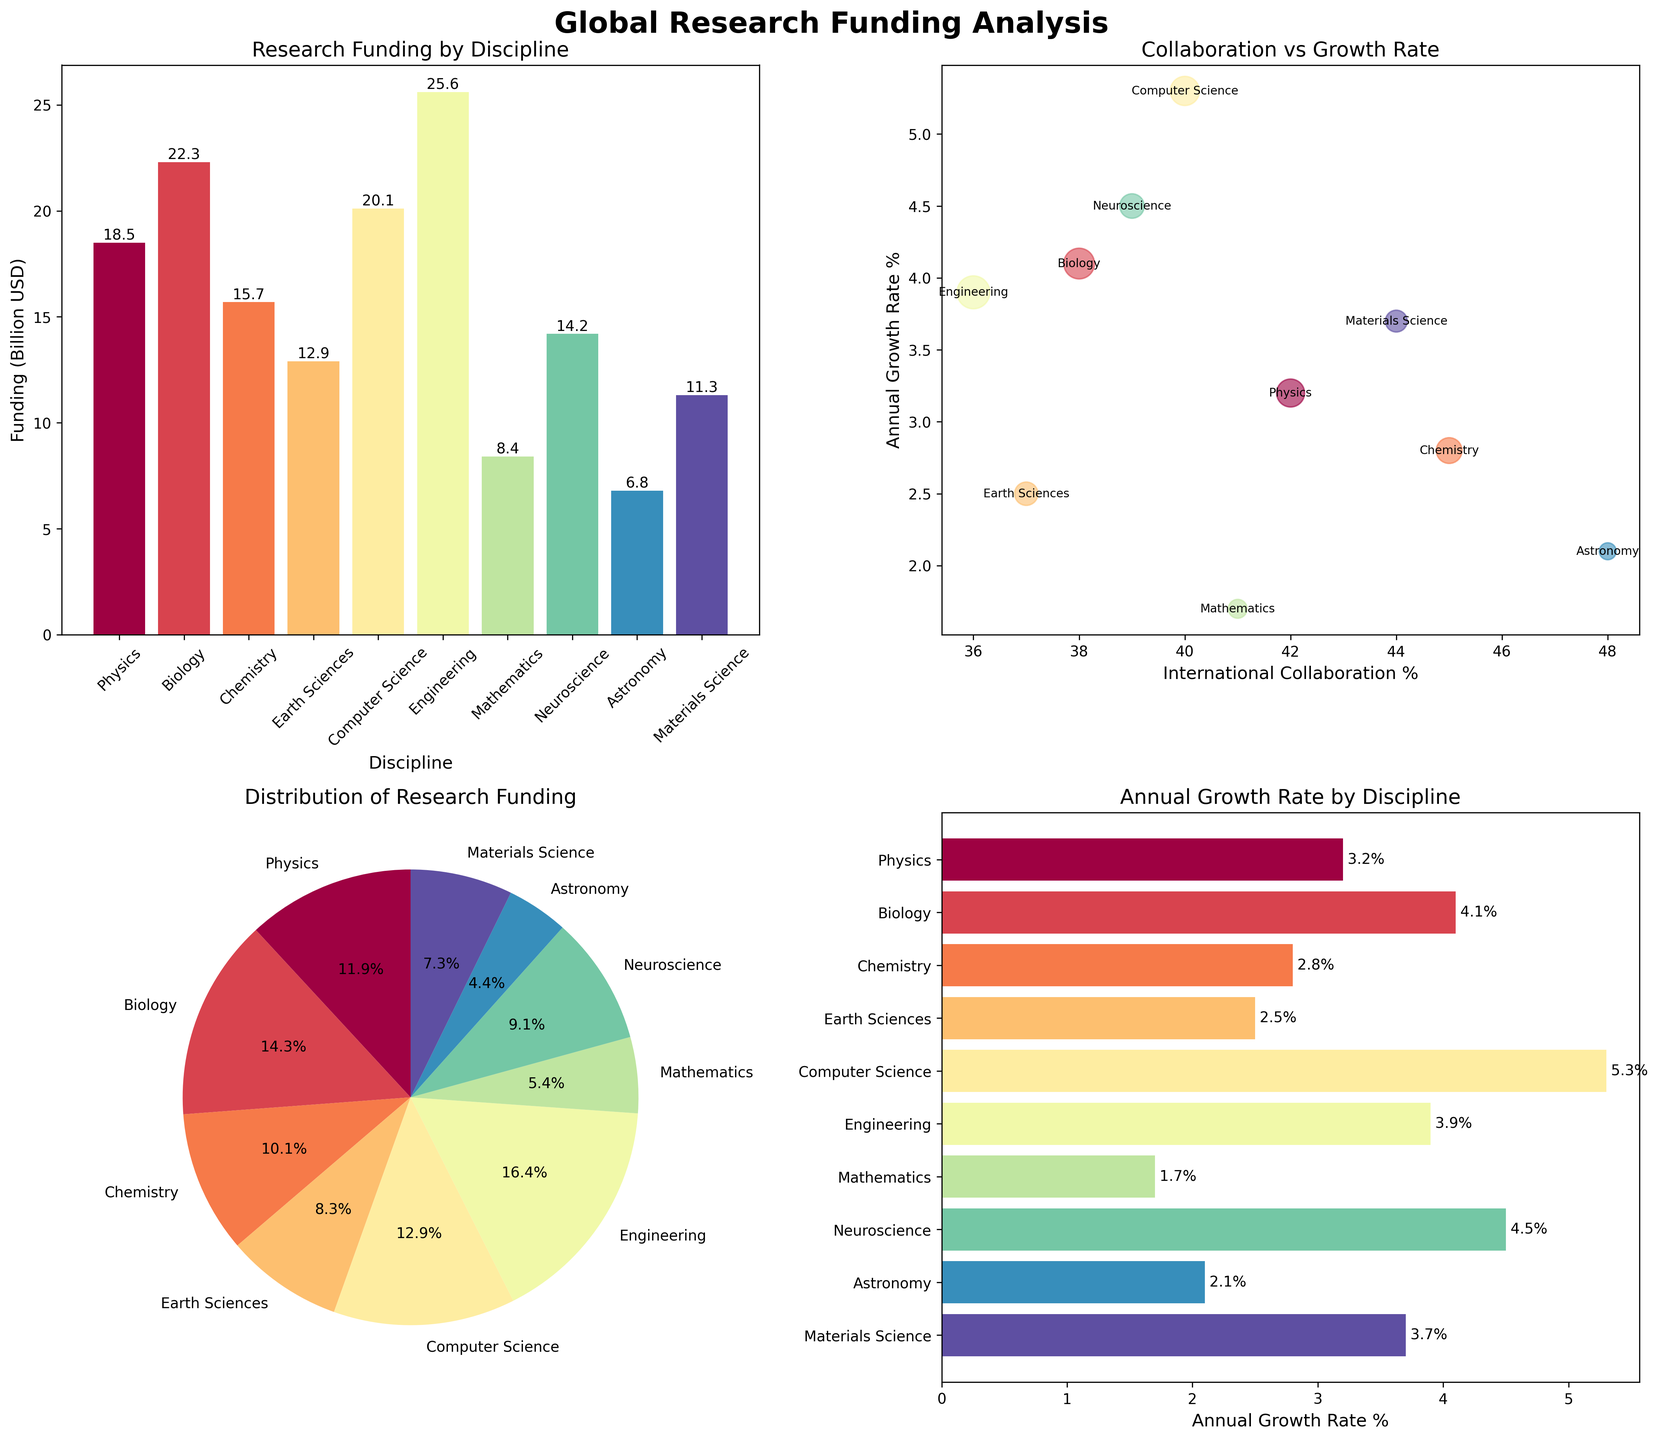What is the title of the bar plot in the figure? The bar plot is the first subplot in the figure’s top-left corner. The title is clearly written above the plot.
Answer: Research Funding by Discipline Which discipline has the highest research funding? In the bar plot, the height of each bar represents funding amounts. The tallest bar corresponds to the highest funding.
Answer: Engineering What is the total research funding across all disciplines? Add together the values of research funding for all the bars in the bar plot. The sum is 18.5 + 22.3 + 15.7 + 12.9 + 20.1 + 25.6 + 8.4 + 14.2 + 6.8 + 11.3.
Answer: 155.8 Billion USD Which discipline has the smallest annual growth rate, and what is it? In the horizontal bar chart, look for the shortest bar, which represents the smallest growth rate. The y-axis labels indicate the corresponding discipline.
Answer: Mathematics, 1.7% How much more funding does Biology receive compared to Mathematics? Compare the heights of the bars in the bar plot for Biology and Mathematics. Subtract Mathematics' funding from Biology's funding: 22.3 - 8.4.
Answer: 13.9 Billion USD What is the relationship between international collaboration percentage and annual growth rate for Physics? In the scatter plot, locate the point labeled "Physics". Its x-coordinate gives the collaboration percentage, and its y-coordinate gives the growth rate.
Answer: 42%, 3.2% Which discipline has the highest percentage of international collaboration? In the scatter plot, identify the data point closest to the rightmost side of the plot (highest x-coordinate). The label indicates the discipline.
Answer: Astronomy Which scientific disciplines have an annual growth rate higher than 4%? In both the scatter plot and horizontal bar chart, look for disciplines with y-coordinates (growth rates) higher than 4%. Identify these points/labels.
Answer: Biology, Computer Science, Neuroscience What is the overall distribution of the research funding among different disciplines? Refer to the pie chart which displays the distribution. The size of each wedge represents the proportion of total funding for each discipline.
Answer: Proportional to the funding with Engineering having the largest slice, followed by Biology, Computer Science, etc Between Computer Science and Earth Sciences, which discipline has a higher annual growth rate and by how much? Compare the lengths of their respective bars in the horizontal bar chart. Subtract Earth Sciences' growth rate from Computer Science's growth rate.
Answer: Computer Science by 2.8% 